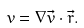Convert formula to latex. <formula><loc_0><loc_0><loc_500><loc_500>v = { \nabla \vec { v } } \cdot \vec { r } .</formula> 